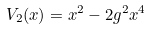Convert formula to latex. <formula><loc_0><loc_0><loc_500><loc_500>V _ { 2 } ( x ) = x ^ { 2 } - 2 g ^ { 2 } x ^ { 4 }</formula> 